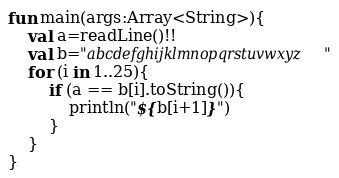<code> <loc_0><loc_0><loc_500><loc_500><_Kotlin_>fun main(args:Array<String>){
    val a=readLine()!!
    val b="abcdefghijklmnopqrstuvwxyz"
    for (i in 1..25){
        if (a == b[i].toString()){
            println("${b[i+1]}")
        }
    }
}</code> 